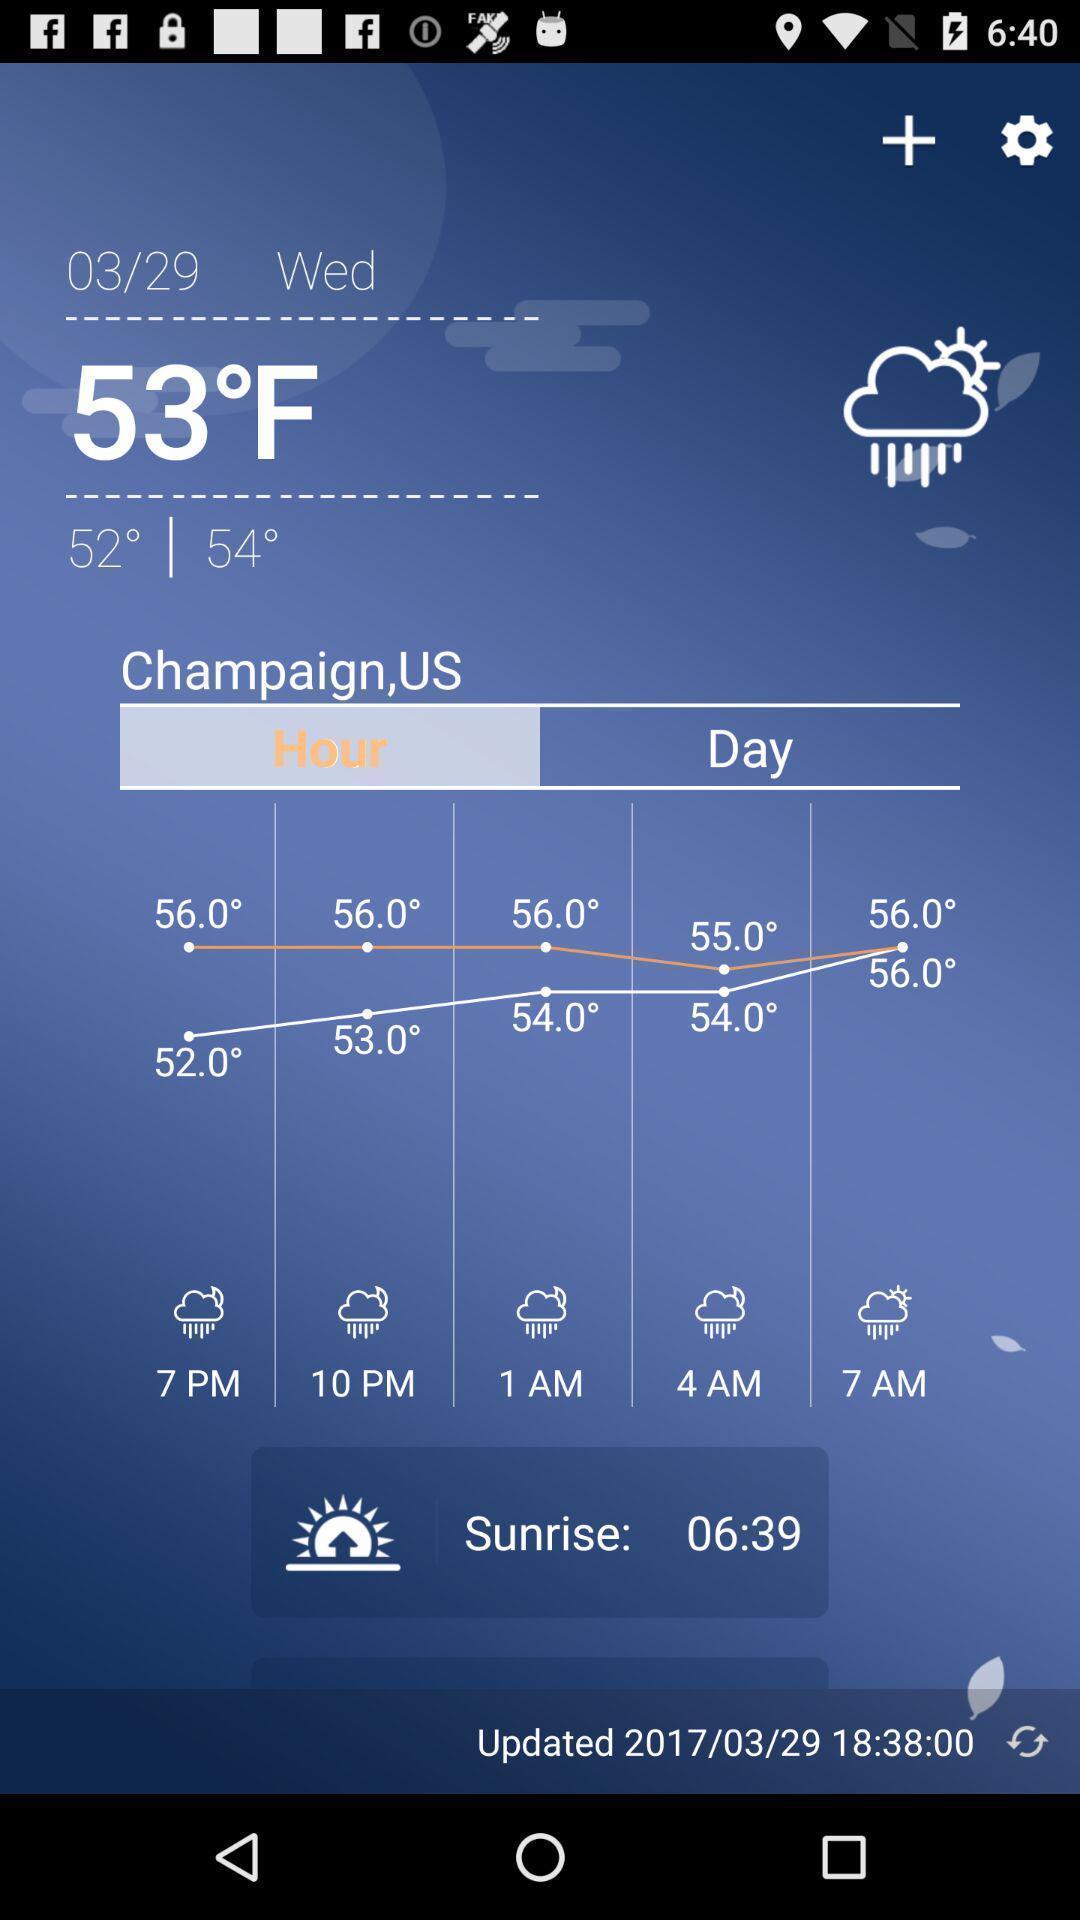Provide a textual representation of this image. Screen is showing weather report page. 